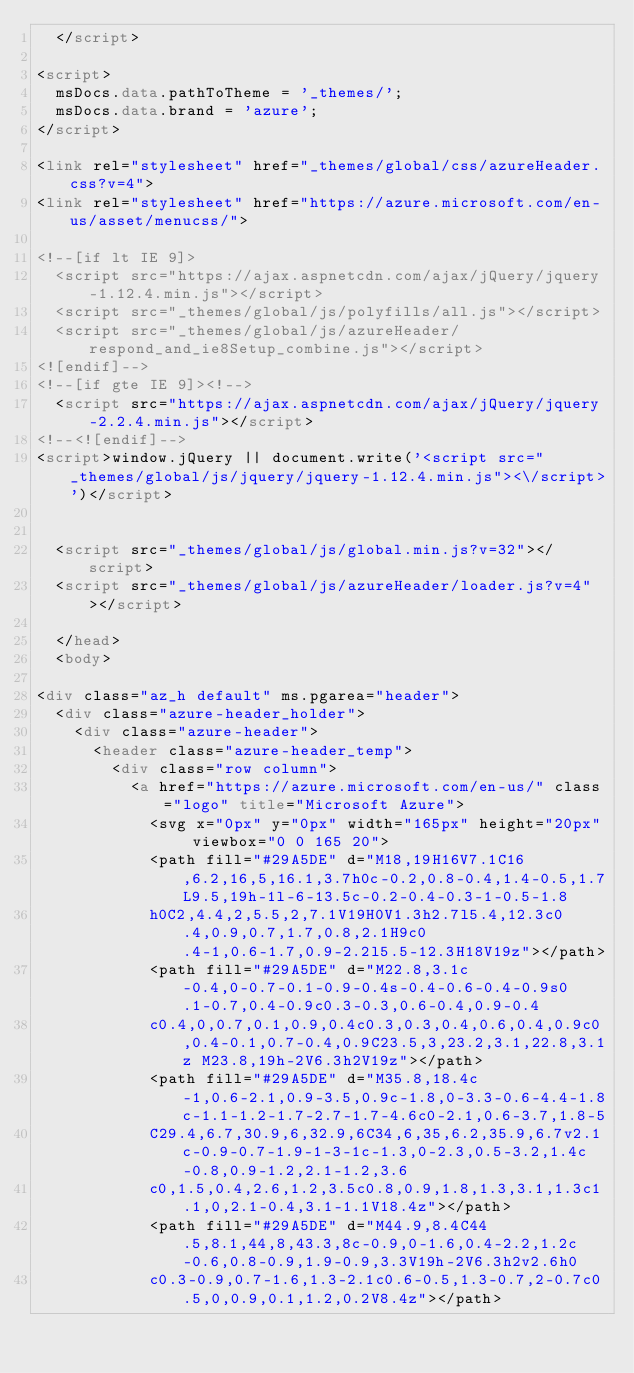<code> <loc_0><loc_0><loc_500><loc_500><_HTML_>	</script>

<script>
	msDocs.data.pathToTheme = '_themes/';
	msDocs.data.brand = 'azure';
</script>

<link rel="stylesheet" href="_themes/global/css/azureHeader.css?v=4">
<link rel="stylesheet" href="https://azure.microsoft.com/en-us/asset/menucss/">

<!--[if lt IE 9]>
	<script src="https://ajax.aspnetcdn.com/ajax/jQuery/jquery-1.12.4.min.js"></script>
	<script src="_themes/global/js/polyfills/all.js"></script>
	<script src="_themes/global/js/azureHeader/respond_and_ie8Setup_combine.js"></script>
<![endif]-->
<!--[if gte IE 9]><!-->
	<script src="https://ajax.aspnetcdn.com/ajax/jQuery/jquery-2.2.4.min.js"></script>
<!--<![endif]-->
<script>window.jQuery || document.write('<script src="_themes/global/js/jquery/jquery-1.12.4.min.js"><\/script>')</script>


  <script src="_themes/global/js/global.min.js?v=32"></script>
  <script src="_themes/global/js/azureHeader/loader.js?v=4"></script>

  </head>
  <body>

<div class="az_h default" ms.pgarea="header">
	<div class="azure-header_holder">	
		<div class="azure-header">	
			<header class="azure-header_temp">
				<div class="row column">
					<a href="https://azure.microsoft.com/en-us/" class="logo" title="Microsoft Azure">
						<svg x="0px" y="0px" width="165px" height="20px" viewbox="0 0 165 20">
						<path fill="#29A5DE" d="M18,19H16V7.1C16,6.2,16,5,16.1,3.7h0c-0.2,0.8-0.4,1.4-0.5,1.7L9.5,19h-1l-6-13.5c-0.2-0.4-0.3-1-0.5-1.8
						h0C2,4.4,2,5.5,2,7.1V19H0V1.3h2.7l5.4,12.3c0.4,0.9,0.7,1.7,0.8,2.1H9c0.4-1,0.6-1.7,0.9-2.2l5.5-12.3H18V19z"></path>
						<path fill="#29A5DE" d="M22.8,3.1c-0.4,0-0.7-0.1-0.9-0.4s-0.4-0.6-0.4-0.9s0.1-0.7,0.4-0.9c0.3-0.3,0.6-0.4,0.9-0.4
						c0.4,0,0.7,0.1,0.9,0.4c0.3,0.3,0.4,0.6,0.4,0.9c0,0.4-0.1,0.7-0.4,0.9C23.5,3,23.2,3.1,22.8,3.1z M23.8,19h-2V6.3h2V19z"></path>
						<path fill="#29A5DE" d="M35.8,18.4c-1,0.6-2.1,0.9-3.5,0.9c-1.8,0-3.3-0.6-4.4-1.8c-1.1-1.2-1.7-2.7-1.7-4.6c0-2.1,0.6-3.7,1.8-5
						C29.4,6.7,30.9,6,32.9,6C34,6,35,6.2,35.9,6.7v2.1c-0.9-0.7-1.9-1-3-1c-1.3,0-2.3,0.5-3.2,1.4c-0.8,0.9-1.2,2.1-1.2,3.6
						c0,1.5,0.4,2.6,1.2,3.5c0.8,0.9,1.8,1.3,3.1,1.3c1.1,0,2.1-0.4,3.1-1.1V18.4z"></path>
						<path fill="#29A5DE" d="M44.9,8.4C44.5,8.1,44,8,43.3,8c-0.9,0-1.6,0.4-2.2,1.2c-0.6,0.8-0.9,1.9-0.9,3.3V19h-2V6.3h2v2.6h0
						c0.3-0.9,0.7-1.6,1.3-2.1c0.6-0.5,1.3-0.7,2-0.7c0.5,0,0.9,0.1,1.2,0.2V8.4z"></path></code> 